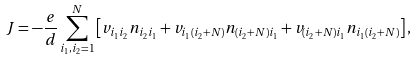<formula> <loc_0><loc_0><loc_500><loc_500>J = - \frac { e } { d } \sum _ { i _ { 1 } , i _ { 2 } = 1 } ^ { N } \left [ v _ { i _ { 1 } i _ { 2 } } n _ { i _ { 2 } i _ { 1 } } + v _ { i _ { 1 } ( i _ { 2 } + N ) } n _ { ( i _ { 2 } + N ) i _ { 1 } } + v _ { ( i _ { 2 } + N ) i _ { 1 } } n _ { i _ { 1 } ( i _ { 2 } + N ) } \right ] ,</formula> 